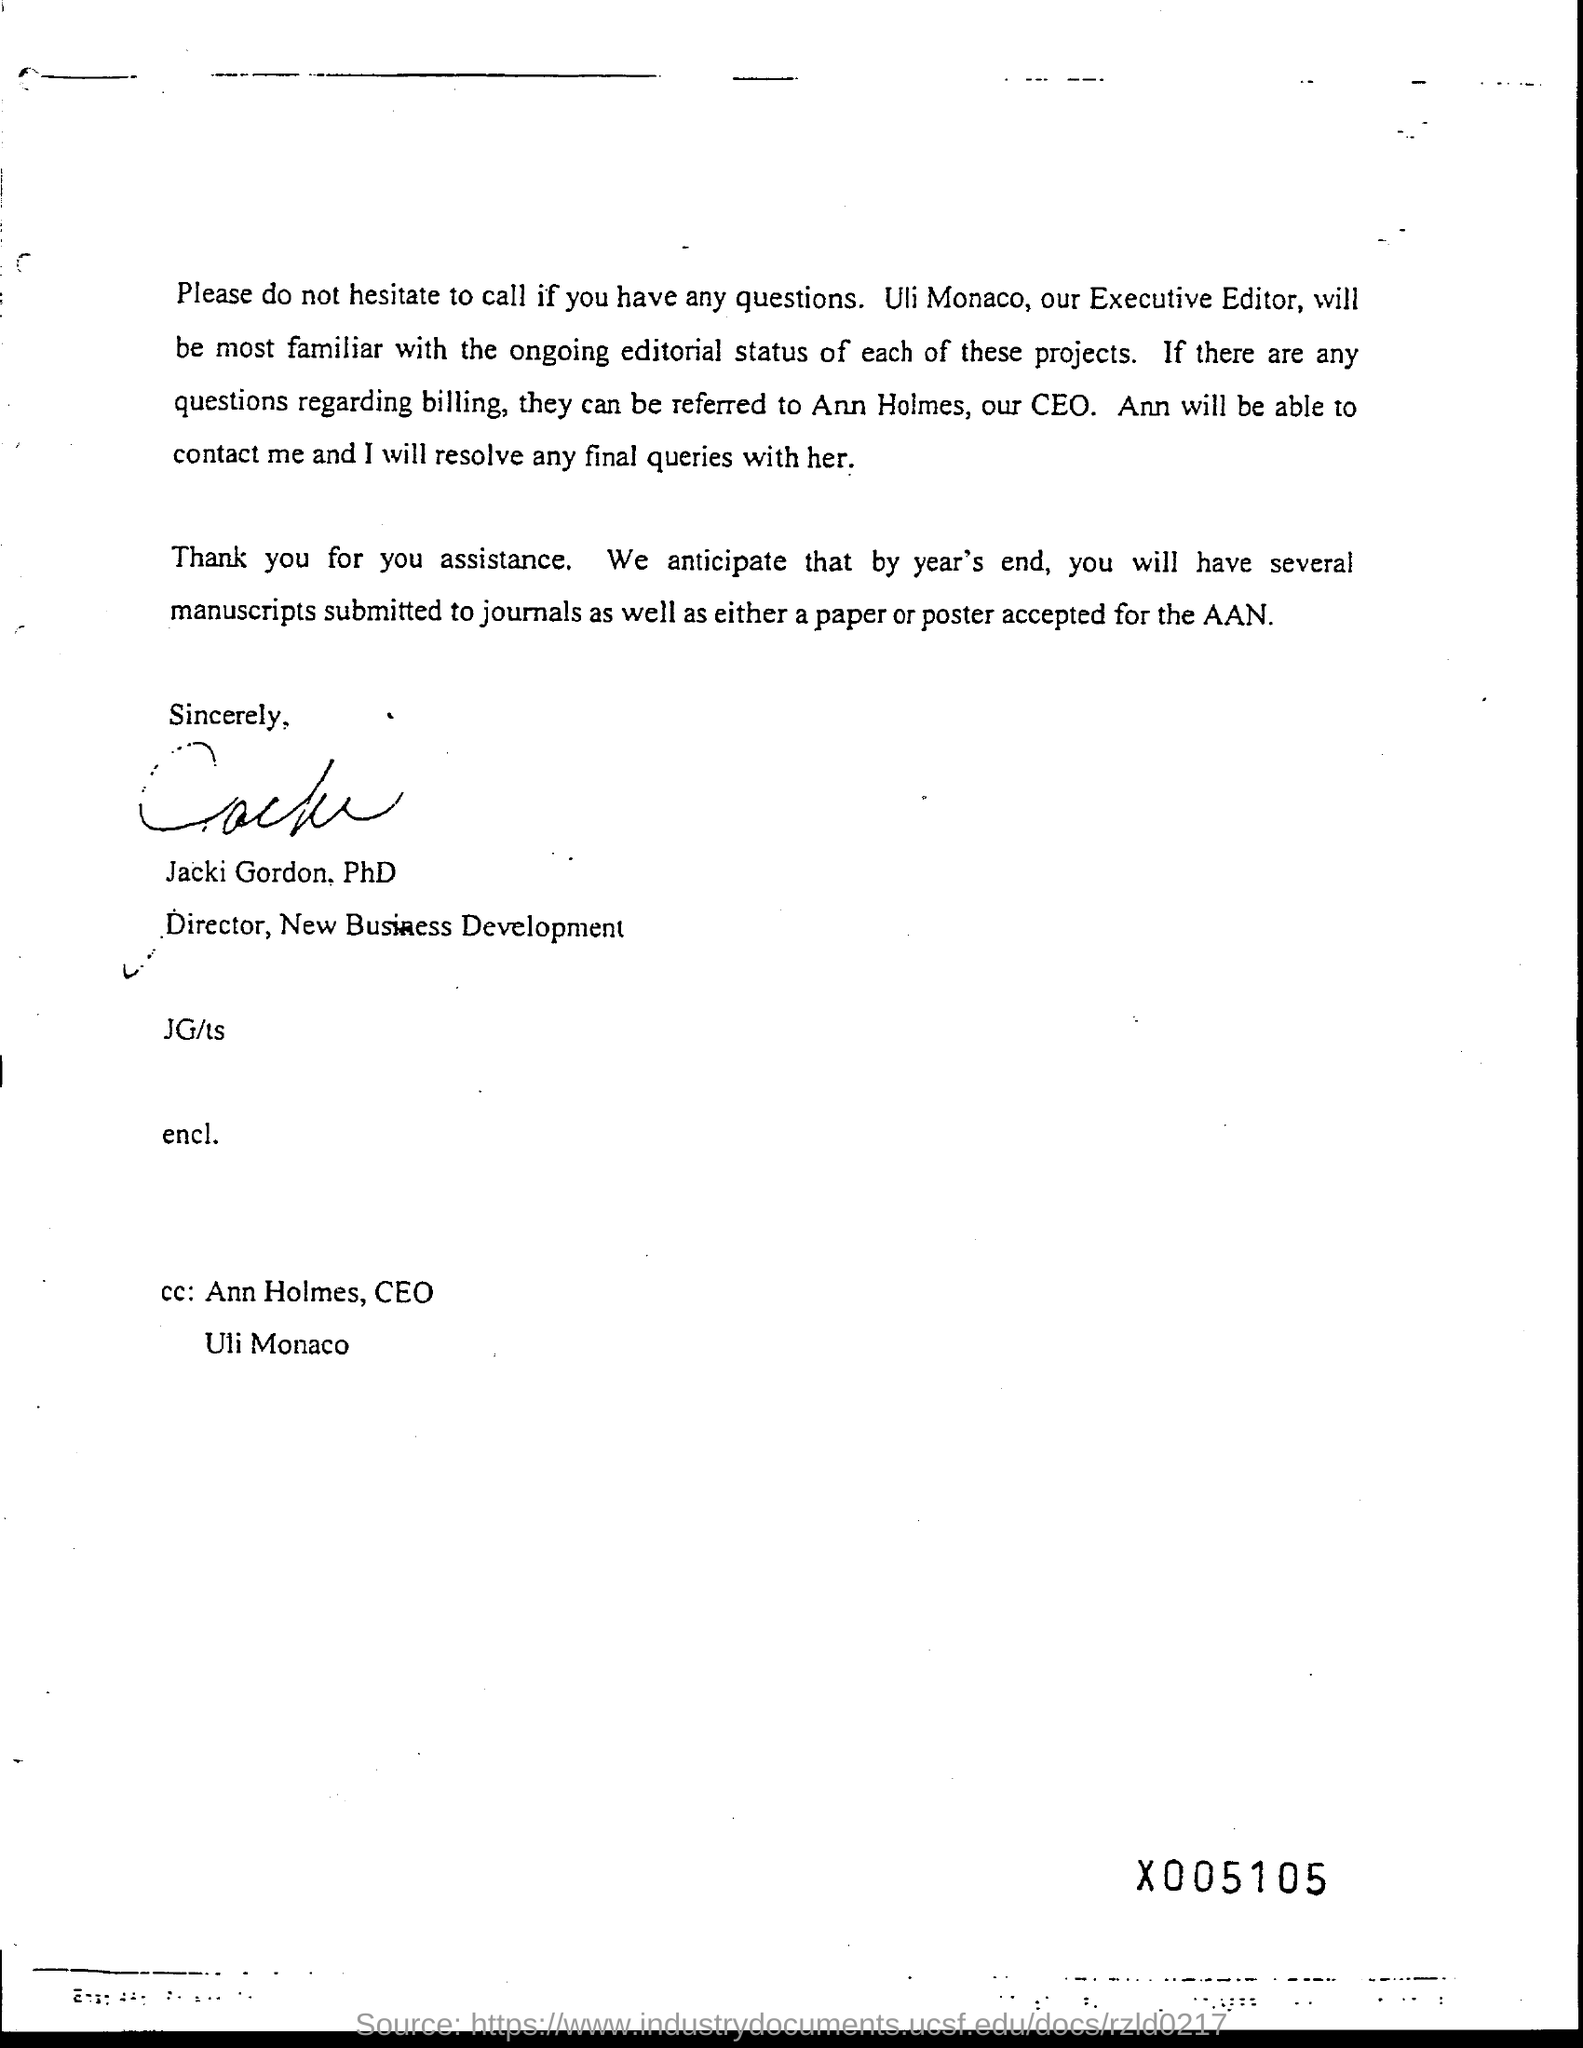What is the designation of Jacki Gordon, PhD?
Make the answer very short. Director, New Business Development. What is the job title of Uli Monaco?
Offer a terse response. EXECUTIVE EDITOR. 